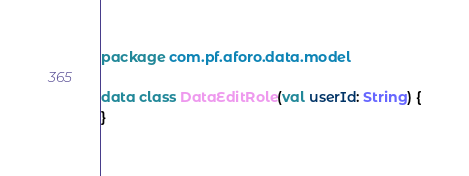<code> <loc_0><loc_0><loc_500><loc_500><_Kotlin_>package com.pf.aforo.data.model

data class DataEditRole(val userId: String) {
}</code> 